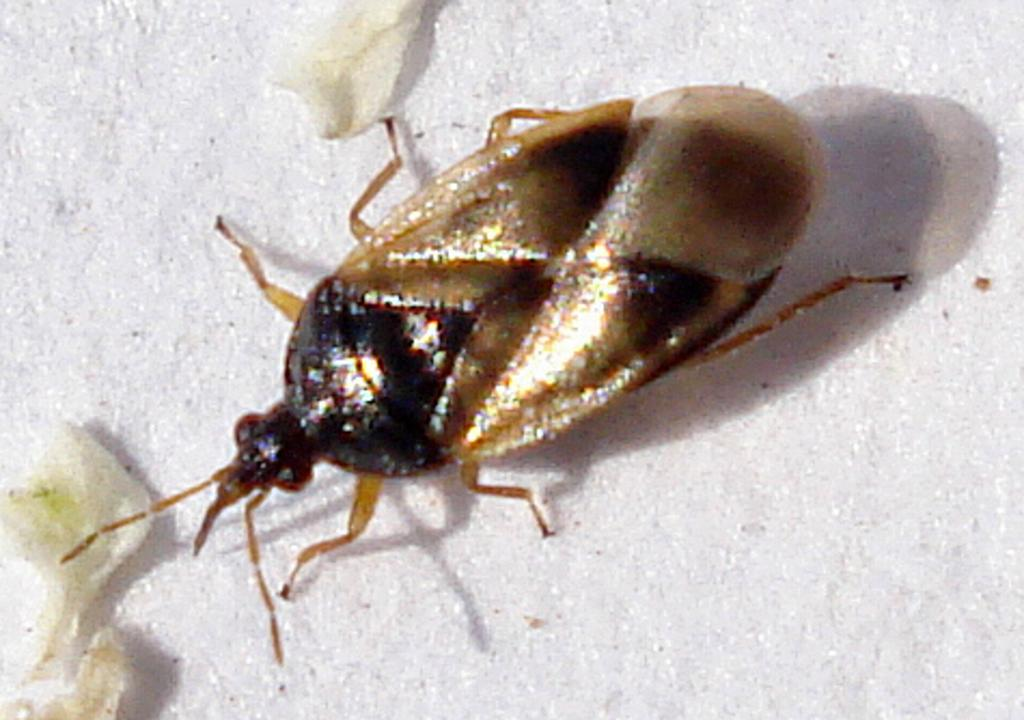What type of insects are present in the image? There are leaf beetles in the image. What are the leaf beetles doing in the image? The leaf beetles are feeding on the surface of flowers or plants. What color is the background of the image? The background of the image is white. What type of drug is the writer using in the image? There is no writer or drug present in the image; it features leaf beetles feeding on flowers or plants with a white background. 